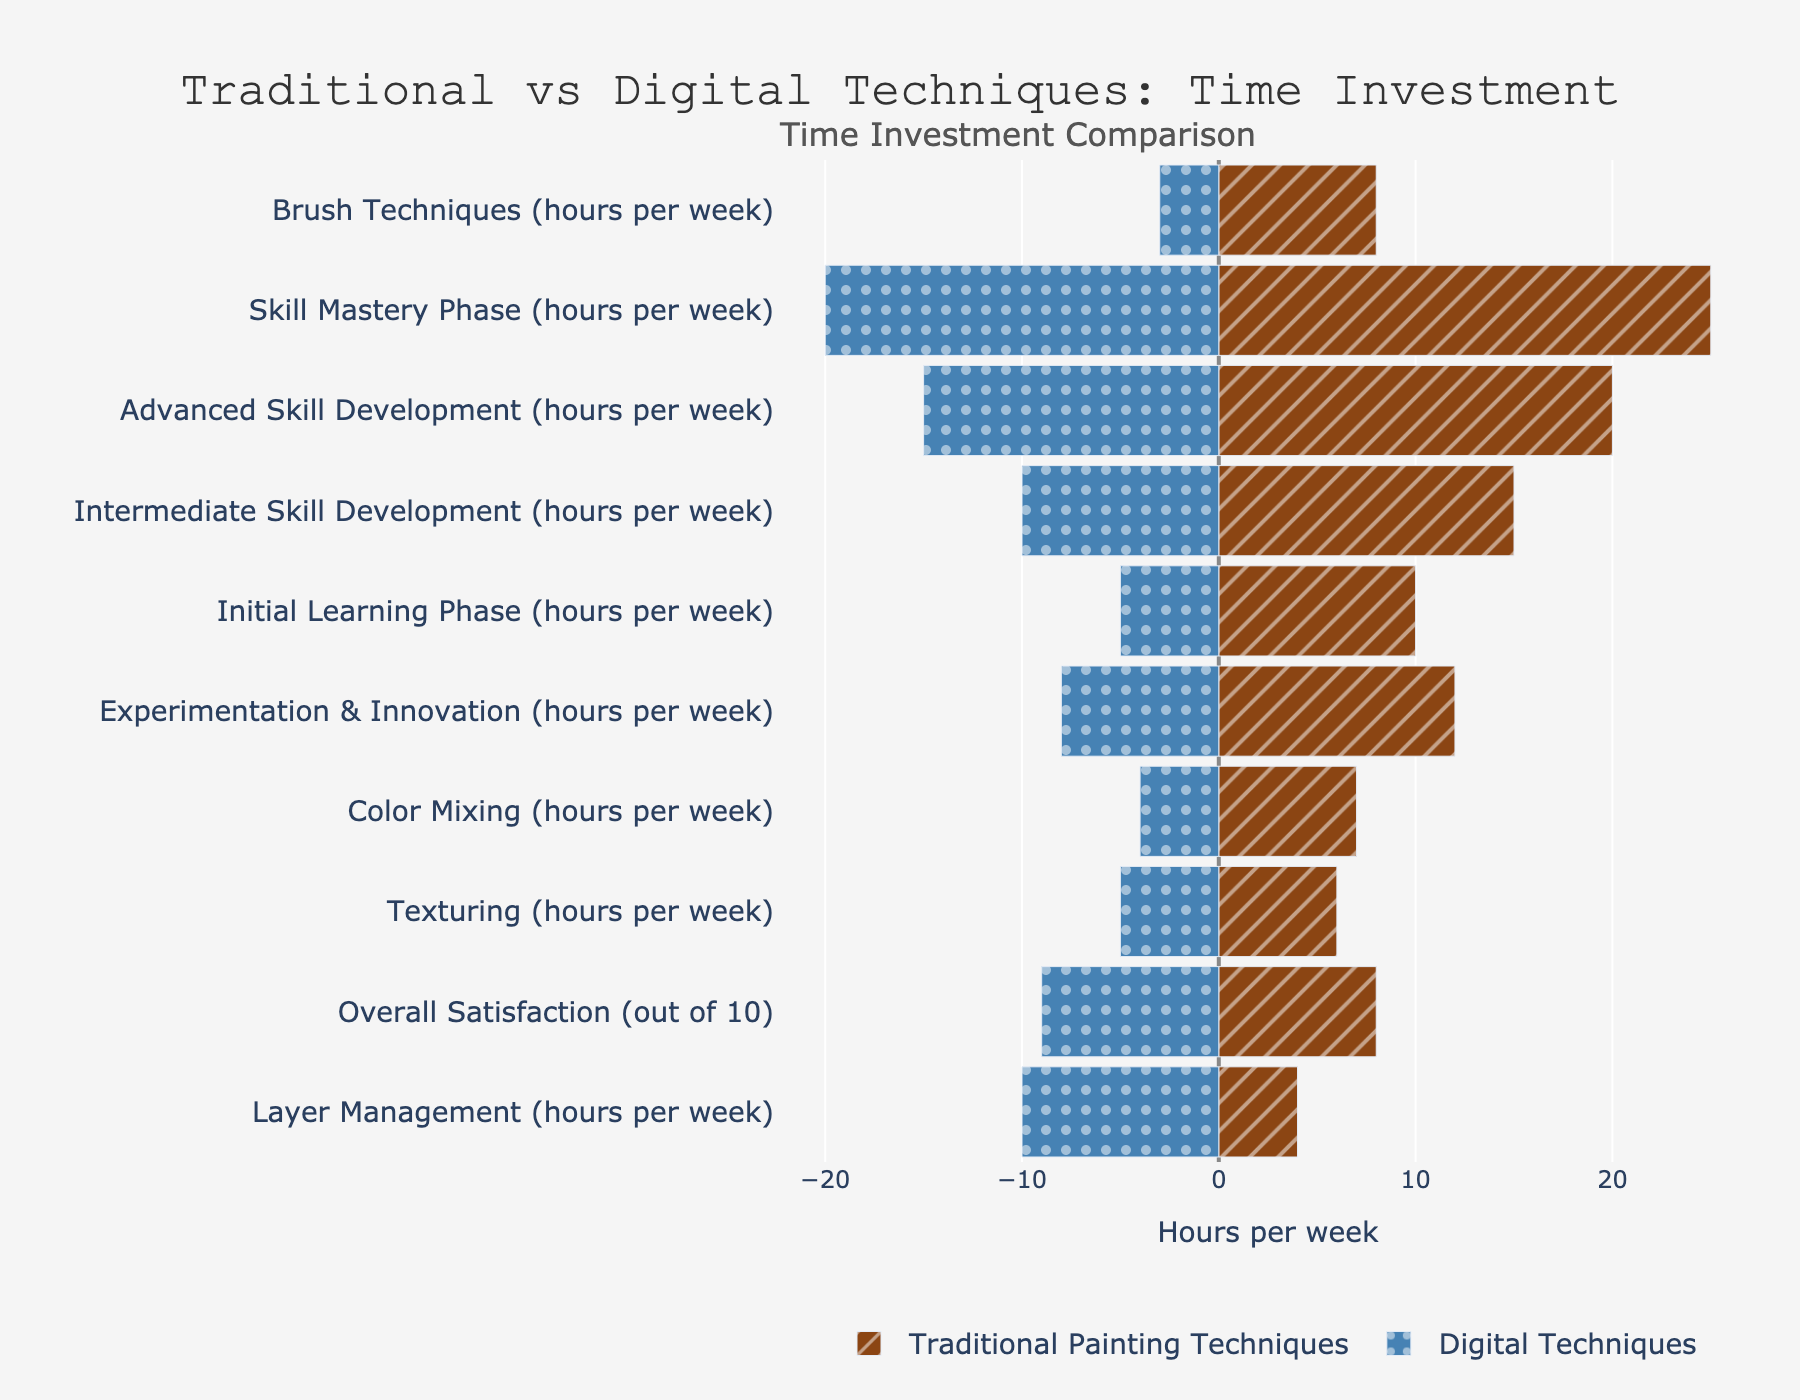What's the difference in time investment between Traditional and Digital Techniques during the Initial Learning Phase? The Traditional Painting Techniques bar shows 10 hours per week, while the Digital Techniques bar is -5 hours per week (indicating 5 hours per week). Thus, Traditional requires 10 - 5 = 5 more hours per week than Digital.
Answer: 5 hours Which technique requires more time in the Skill Mastery Phase? The bar for Traditional Painting Techniques is at 25 hours per week, whereas the bar for Digital Techniques is at -20 hours per week. This means Traditional Techniques require more time.
Answer: Traditional Painting Techniques By how many hours per week does Traditional Painting Techniques surpass Digital Techniques in Intermediate Skill Development? The bar for Traditional Painting Techniques shows 15 hours per week, while Digital Techniques is at -10 hours per week. The difference is 15 - 10 = 5 hours per week.
Answer: 5 hours What is the sum of hours per week spent on Brush Techniques and Color Mixing for Traditional Painting Techniques? The bars indicate 8 hours for Brush Techniques and 7 hours for Color Mixing in Traditional Painting Techniques. Summing these gives 8 + 7 = 15 hours per week.
Answer: 15 hours Which category shows the largest time investment difference between Traditional and Digital Techniques? The Skill Mastery Phase shows the largest difference with Traditional Painting Techniques at 25 hours and Digital Techniques at -20 hours, resulting in a difference of 25 - 20 = 5 hours per week.
Answer: Skill Mastery Phase Which technique has higher overall satisfaction and by how much? The bar for Overall Satisfaction in Traditional Painting Techniques is 8/10, whereas for Digital Techniques it's 9/10, indicating Digital Techniques have a higher satisfaction by 9 - 8 = 1 point.
Answer: Digital Techniques by 1 point In which categories do Digital Techniques require more hours than Traditional Techniques? The Layer Management category shows Digital Techniques (-10 hours) requiring more hours than Traditional (-4 hours), indicating more time in Digital Techniques.
Answer: Layer Management What's the average time investment per week for Advanced Skill Development across both techniques? For Advanced Skill Development, Traditional Techniques require 20 hours and Digital Techniques require 15 hours. The average is (20 + 15) / 2 = 17.5 hours per week.
Answer: 17.5 hours What is the ratio of time spent on Experimentation & Innovation between Traditional and Digital Techniques? Traditional Painting Techniques require 12 hours per week while Digital Techniques require -8 hours per week. The ratio is 12:8 or simplified 3:2.
Answer: 3:2 Which technique has a wider range of time investment across all categories? The range for Traditional goes from 4 to 25 hours per week (a span of 21 hours), while Digital spans from 3 to 20 hours per week (a span of 17 hours). Thus, Traditional Techniques have a wider range.
Answer: Traditional Painting Techniques 